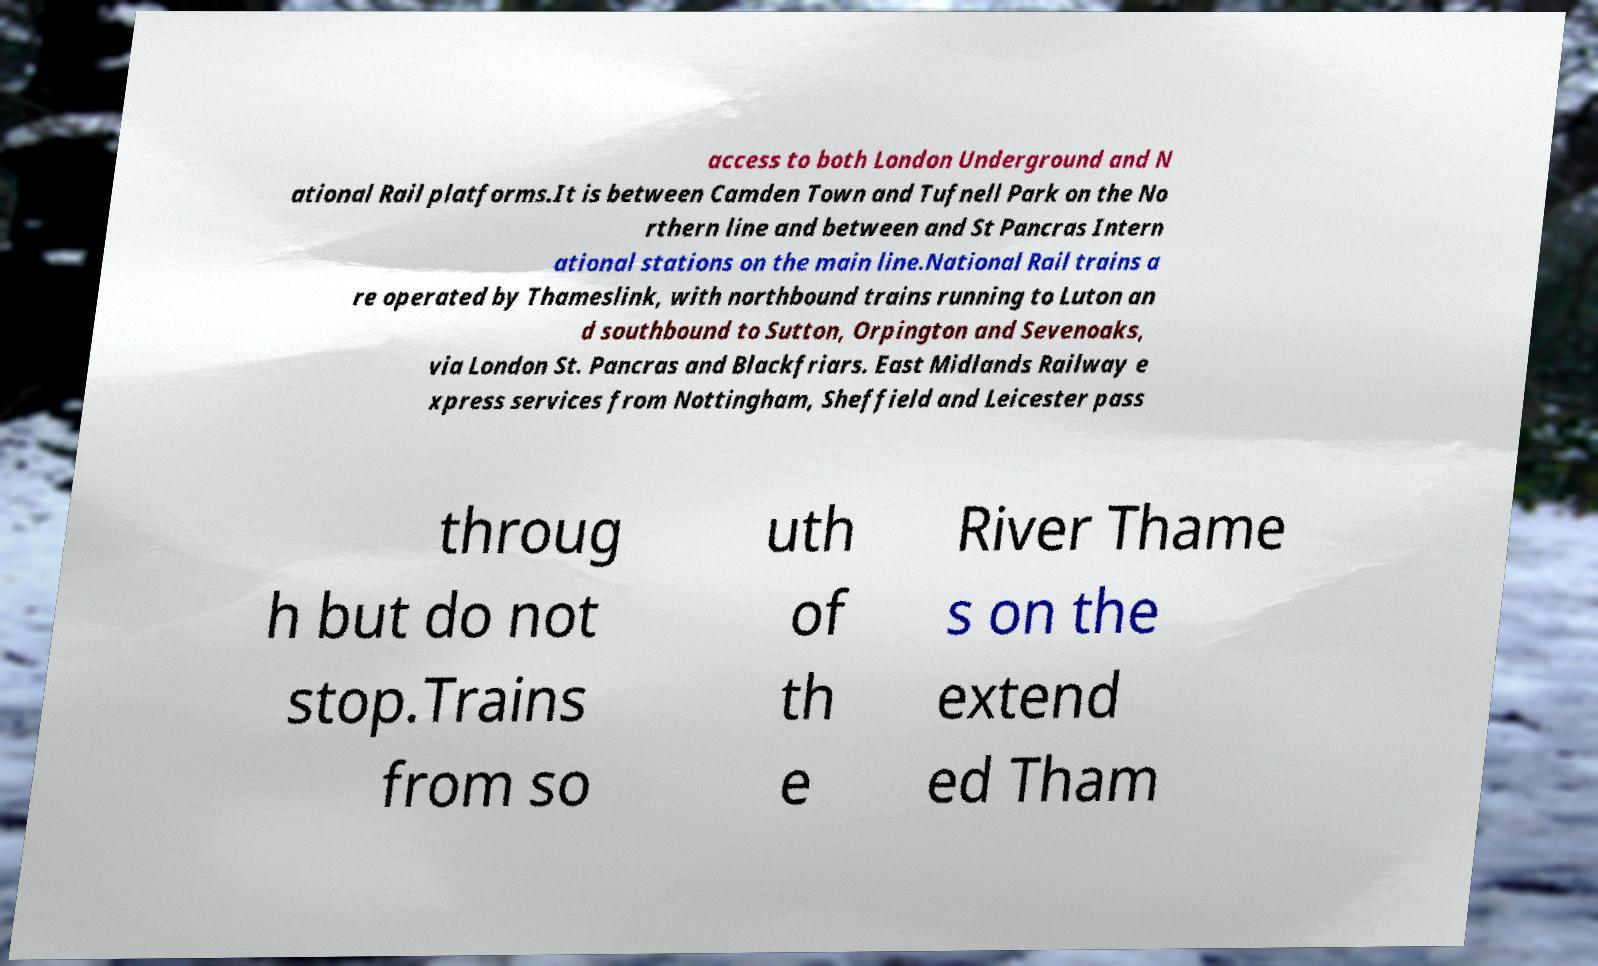What messages or text are displayed in this image? I need them in a readable, typed format. access to both London Underground and N ational Rail platforms.It is between Camden Town and Tufnell Park on the No rthern line and between and St Pancras Intern ational stations on the main line.National Rail trains a re operated by Thameslink, with northbound trains running to Luton an d southbound to Sutton, Orpington and Sevenoaks, via London St. Pancras and Blackfriars. East Midlands Railway e xpress services from Nottingham, Sheffield and Leicester pass throug h but do not stop.Trains from so uth of th e River Thame s on the extend ed Tham 